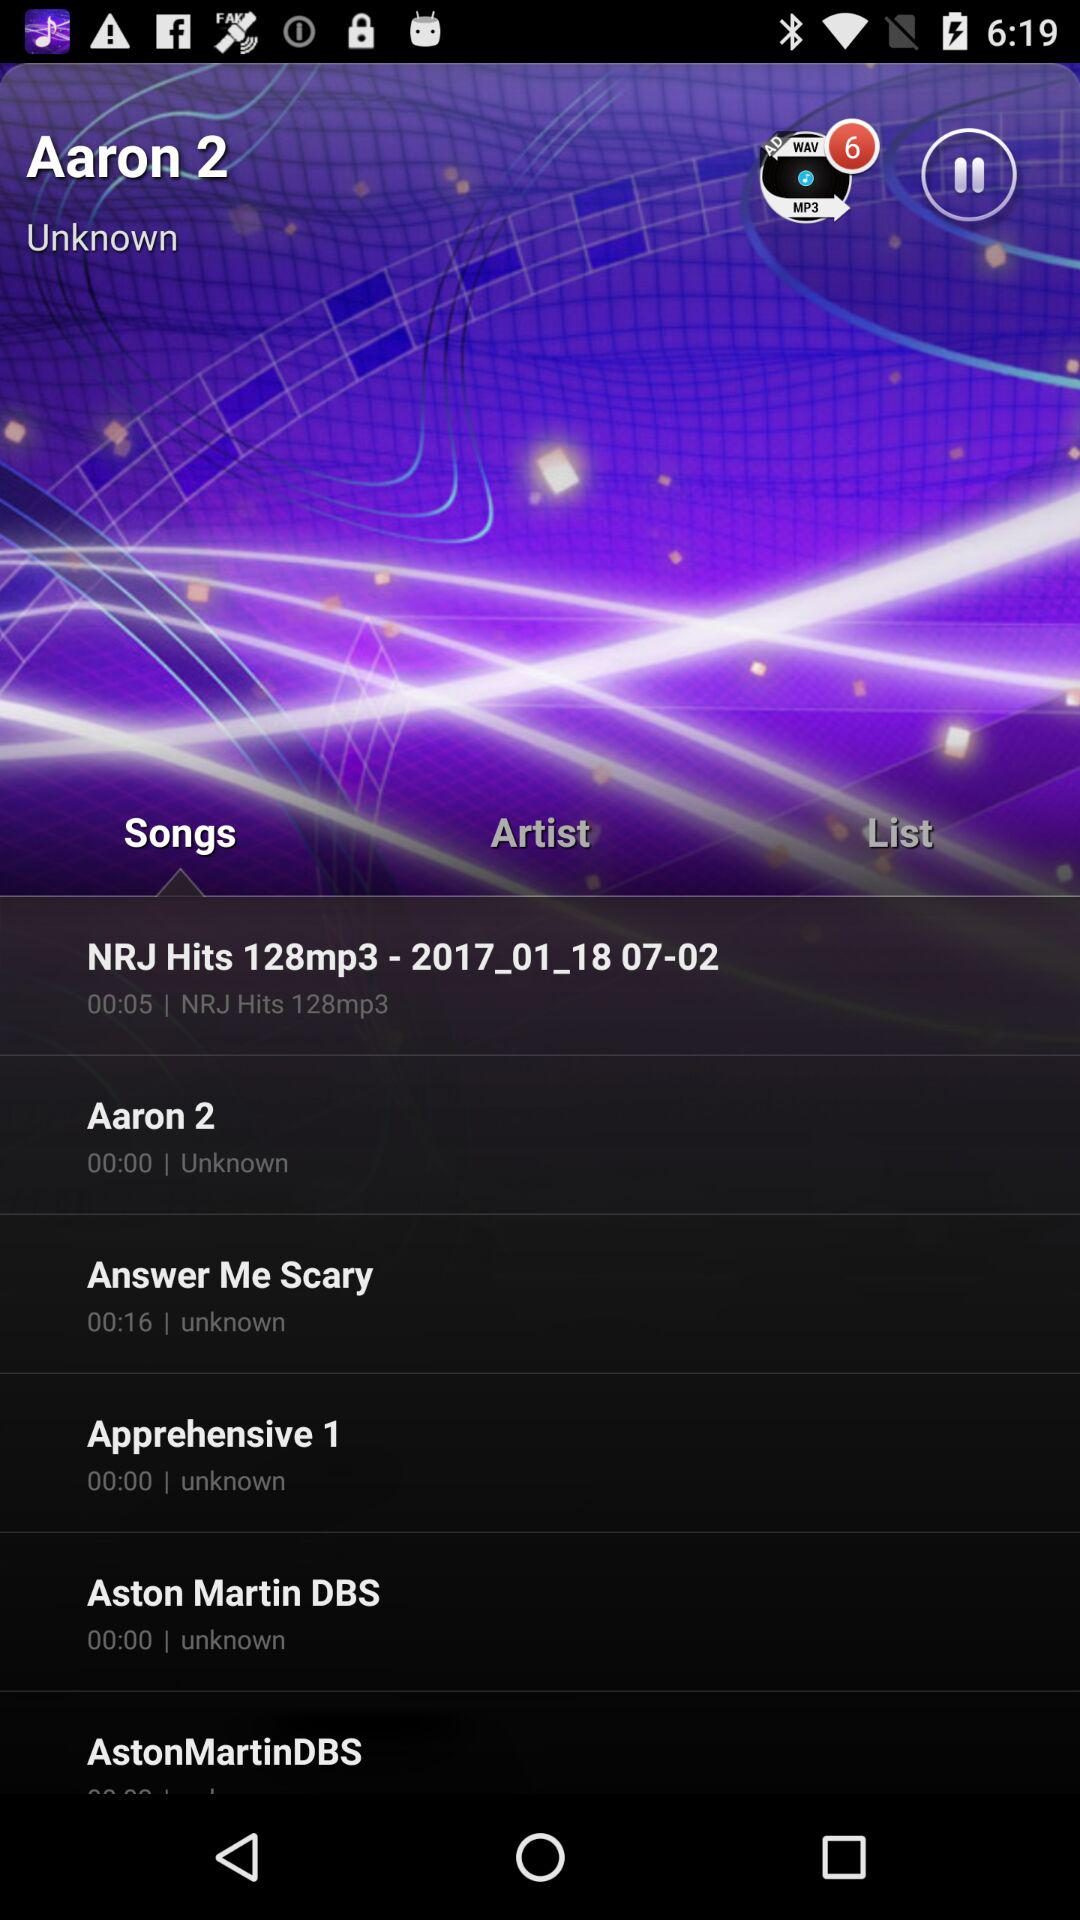How many more seconds is the song Answer Me Scary than Aston Martin DBS?
Answer the question using a single word or phrase. 16 